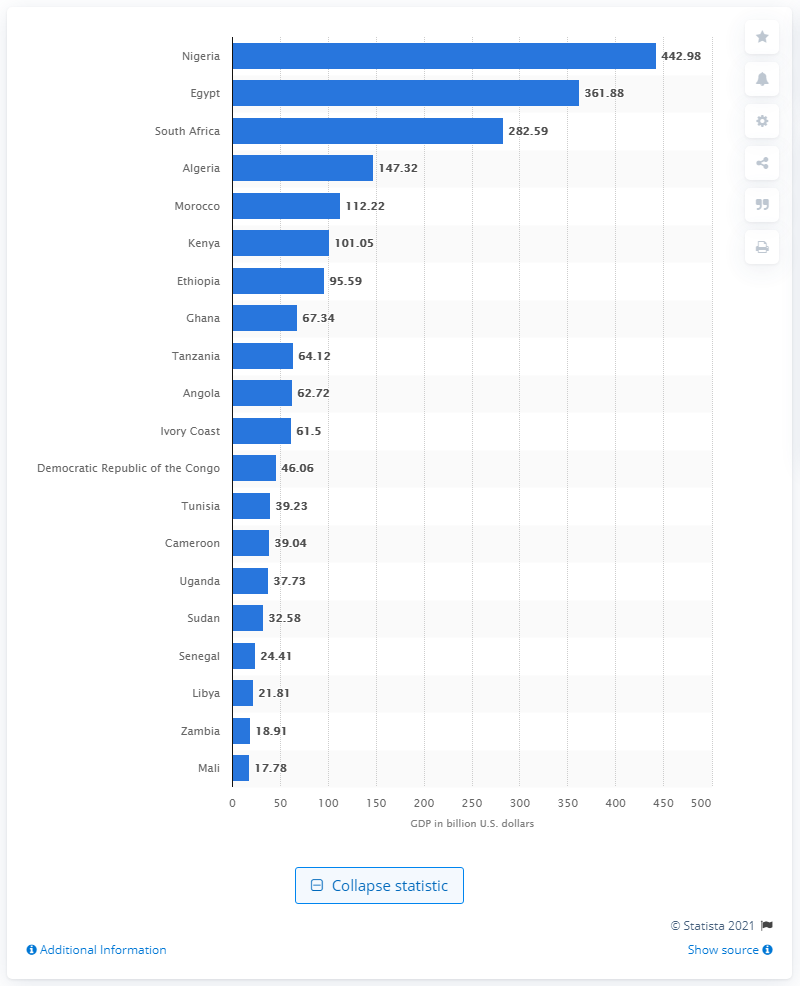Point out several critical features in this image. Egypt has the second-highest GDP among the countries on the continent. Nigeria's Gross Domestic Product (GDP) in dollars in 2020 was $442.98 billion. 